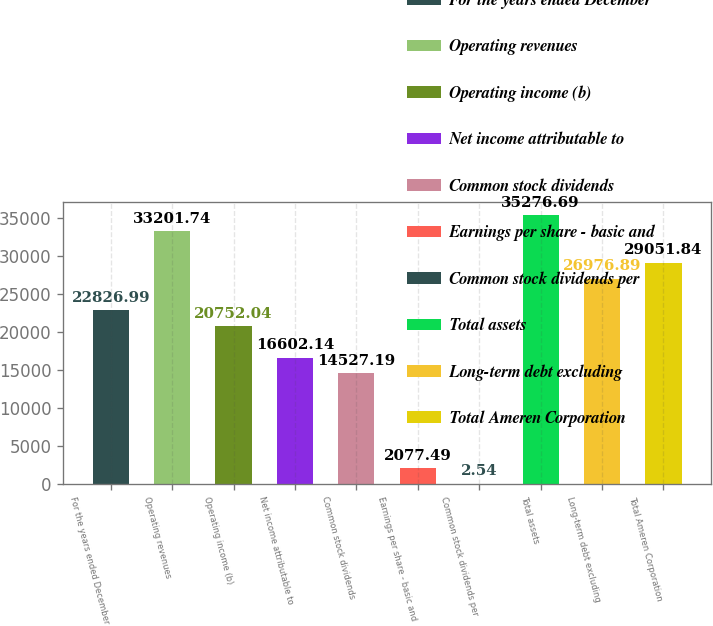Convert chart. <chart><loc_0><loc_0><loc_500><loc_500><bar_chart><fcel>For the years ended December<fcel>Operating revenues<fcel>Operating income (b)<fcel>Net income attributable to<fcel>Common stock dividends<fcel>Earnings per share - basic and<fcel>Common stock dividends per<fcel>Total assets<fcel>Long-term debt excluding<fcel>Total Ameren Corporation<nl><fcel>22827<fcel>33201.7<fcel>20752<fcel>16602.1<fcel>14527.2<fcel>2077.49<fcel>2.54<fcel>35276.7<fcel>26976.9<fcel>29051.8<nl></chart> 